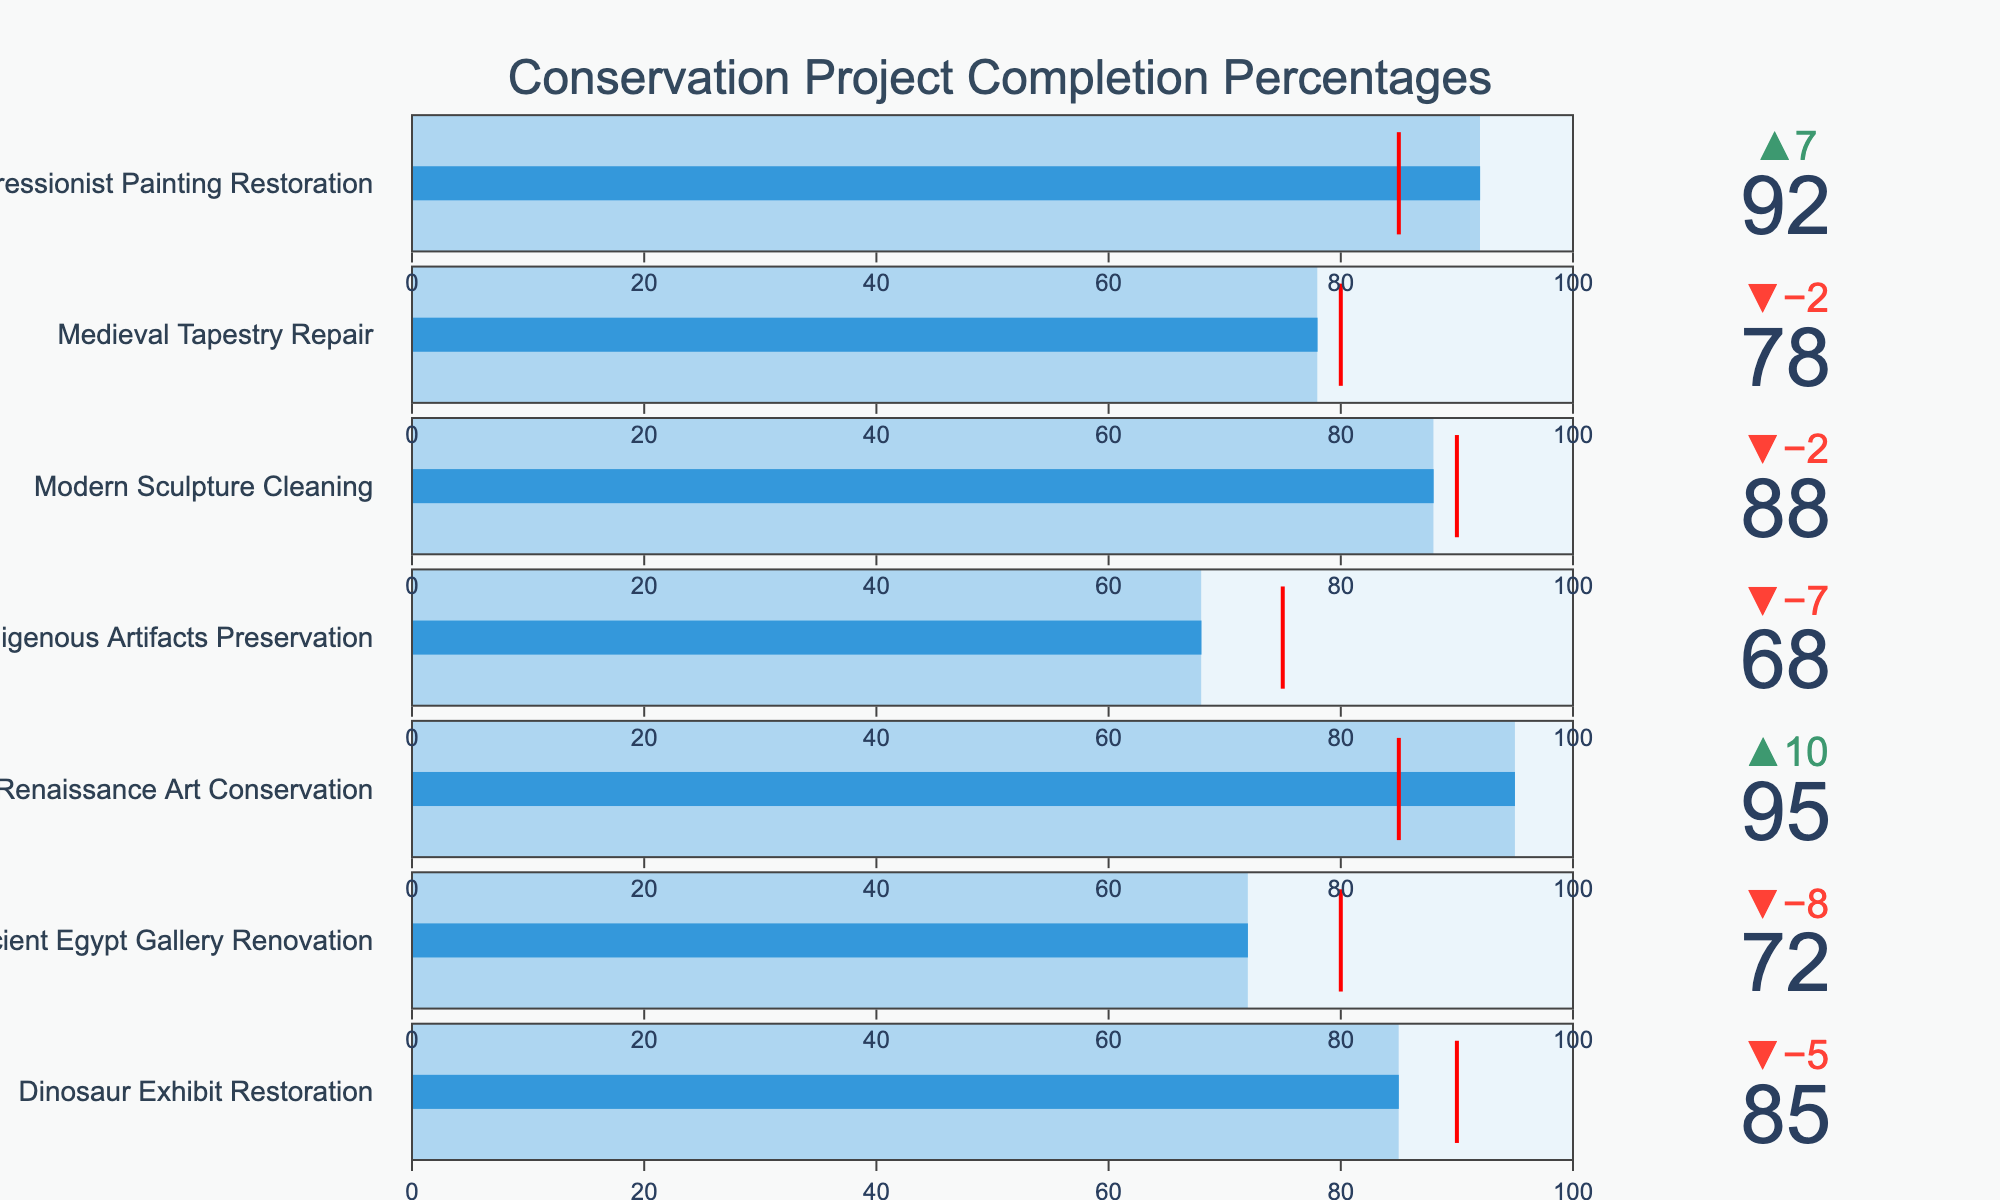What is the title of the chart? The title is located at the top center of the figure. It indicates the overall focus of the visual content. The title of the chart is "Conservation Project Completion Percentages".
Answer: Conservation Project Completion Percentages How many conservation projects are displayed in the chart? By counting the number of different project titles listed on the chart, we can determine there are seven projects. Each project is represented by a separate bullet graph.
Answer: 7 Which project has the highest actual completion percentage? The actual completion percentages are shown by the bars within each bullet chart. By visually comparing the lengths of these bars, we see that 95% is the highest value among all the projects. The "Renaissance Art Conservation" project has this percentage.
Answer: Renaissance Art Conservation Did the "Modern Sculpture Cleaning" project meet its target? By examining the bullet chart for the "Modern Sculpture Cleaning" project, we can see the actual completion percentage (88%) and compare it to the target (90%) marked by a red line. Since 88% is less than 90%, it did not meet its target.
Answer: No What is the difference between the actual and target completion percentages for the "Impressionist Painting Restoration" project? To find the difference, subtract the target percentage from the actual percentage for "Impressionist Painting Restoration". Actual (92%) - Target (85%) = 7%.
Answer: 7% Which project has the smallest gap between its actual completion and target? By calculating the difference between actual and target percentages for each project, we can find the smallest gap. The projects' differences are 5% (Dinosaur Exhibit Restoration), 8% (Ancient Egypt Gallery Renovation), -10% (Renaissance Art Conservation), 7% (Indigenous Artifacts Preservation), 2% (Modern Sculpture Cleaning), 2% (Medieval Tapestry Repair), and 7% (Impressionist Painting Restoration). The "Medieval Tapestry Repair" and "Modern Sculpture Cleaning" both have the smallest gap at 2%.
Answer: Modern Sculpture Cleaning, Medieval Tapestry Repair Which project exceeded its target completion percentage by the largest margin? To find which project exceeded its target by the largest margin, compare the deltas (differences between actual and target) for projects exceeding their targets. The largest positive delta is found for "Renaissance Art Conservation" at 10%.
Answer: Renaissance Art Conservation How many projects had an actual completion percentage greater than or equal to 85%? Count the projects where the bar representing the actual completion percentage reaches or exceeds 85%. These projects are Dinosaur Exhibit Restoration (85%), Renaissance Art Conservation (95%), Modern Sculpture Cleaning (88%), and Impressionist Painting Restoration (92%). There are four such projects.
Answer: 4 